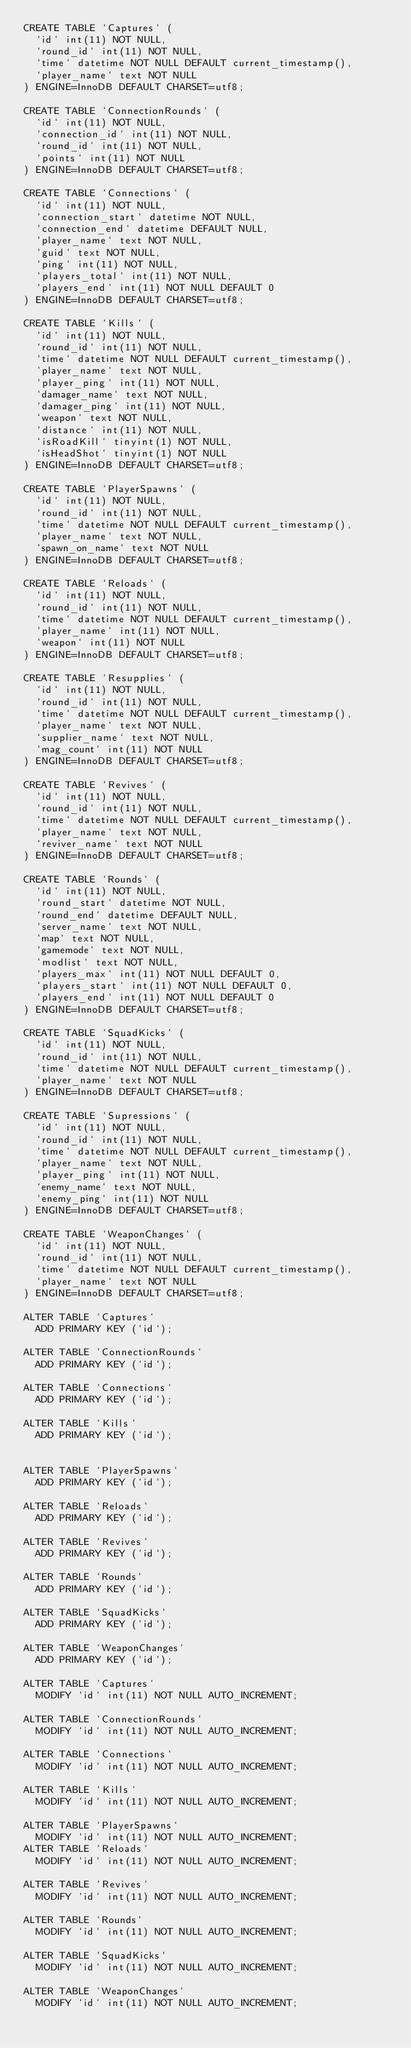Convert code to text. <code><loc_0><loc_0><loc_500><loc_500><_SQL_>CREATE TABLE `Captures` (
  `id` int(11) NOT NULL,
  `round_id` int(11) NOT NULL,
  `time` datetime NOT NULL DEFAULT current_timestamp(),
  `player_name` text NOT NULL
) ENGINE=InnoDB DEFAULT CHARSET=utf8;

CREATE TABLE `ConnectionRounds` (
  `id` int(11) NOT NULL,
  `connection_id` int(11) NOT NULL,
  `round_id` int(11) NOT NULL,
  `points` int(11) NOT NULL
) ENGINE=InnoDB DEFAULT CHARSET=utf8;

CREATE TABLE `Connections` (
  `id` int(11) NOT NULL,
  `connection_start` datetime NOT NULL,
  `connection_end` datetime DEFAULT NULL,
  `player_name` text NOT NULL,
  `guid` text NOT NULL,
  `ping` int(11) NOT NULL,
  `players_total` int(11) NOT NULL,
  `players_end` int(11) NOT NULL DEFAULT 0
) ENGINE=InnoDB DEFAULT CHARSET=utf8;

CREATE TABLE `Kills` (
  `id` int(11) NOT NULL,
  `round_id` int(11) NOT NULL,
  `time` datetime NOT NULL DEFAULT current_timestamp(),
  `player_name` text NOT NULL,
  `player_ping` int(11) NOT NULL,
  `damager_name` text NOT NULL,
  `damager_ping` int(11) NOT NULL,
  `weapon` text NOT NULL,
  `distance` int(11) NOT NULL,
  `isRoadKill` tinyint(1) NOT NULL,
  `isHeadShot` tinyint(1) NOT NULL
) ENGINE=InnoDB DEFAULT CHARSET=utf8;

CREATE TABLE `PlayerSpawns` (
  `id` int(11) NOT NULL,
  `round_id` int(11) NOT NULL,
  `time` datetime NOT NULL DEFAULT current_timestamp(),
  `player_name` text NOT NULL,
  `spawn_on_name` text NOT NULL
) ENGINE=InnoDB DEFAULT CHARSET=utf8;

CREATE TABLE `Reloads` (
  `id` int(11) NOT NULL,
  `round_id` int(11) NOT NULL,
  `time` datetime NOT NULL DEFAULT current_timestamp(),
  `player_name` int(11) NOT NULL,
  `weapon` int(11) NOT NULL
) ENGINE=InnoDB DEFAULT CHARSET=utf8;

CREATE TABLE `Resupplies` (
  `id` int(11) NOT NULL,
  `round_id` int(11) NOT NULL,
  `time` datetime NOT NULL DEFAULT current_timestamp(),
  `player_name` text NOT NULL,
  `supplier_name` text NOT NULL,
  `mag_count` int(11) NOT NULL
) ENGINE=InnoDB DEFAULT CHARSET=utf8;

CREATE TABLE `Revives` (
  `id` int(11) NOT NULL,
  `round_id` int(11) NOT NULL,
  `time` datetime NOT NULL DEFAULT current_timestamp(),
  `player_name` text NOT NULL,
  `reviver_name` text NOT NULL
) ENGINE=InnoDB DEFAULT CHARSET=utf8;

CREATE TABLE `Rounds` (
  `id` int(11) NOT NULL,
  `round_start` datetime NOT NULL,
  `round_end` datetime DEFAULT NULL,
  `server_name` text NOT NULL,
  `map` text NOT NULL,
  `gamemode` text NOT NULL,
  `modlist` text NOT NULL,
  `players_max` int(11) NOT NULL DEFAULT 0,
  `players_start` int(11) NOT NULL DEFAULT 0,
  `players_end` int(11) NOT NULL DEFAULT 0
) ENGINE=InnoDB DEFAULT CHARSET=utf8;

CREATE TABLE `SquadKicks` (
  `id` int(11) NOT NULL,
  `round_id` int(11) NOT NULL,
  `time` datetime NOT NULL DEFAULT current_timestamp(),
  `player_name` text NOT NULL
) ENGINE=InnoDB DEFAULT CHARSET=utf8;

CREATE TABLE `Supressions` (
  `id` int(11) NOT NULL,
  `round_id` int(11) NOT NULL,
  `time` datetime NOT NULL DEFAULT current_timestamp(),
  `player_name` text NOT NULL,
  `player_ping` int(11) NOT NULL,
  `enemy_name` text NOT NULL,
  `enemy_ping` int(11) NOT NULL
) ENGINE=InnoDB DEFAULT CHARSET=utf8;

CREATE TABLE `WeaponChanges` (
  `id` int(11) NOT NULL,
  `round_id` int(11) NOT NULL,
  `time` datetime NOT NULL DEFAULT current_timestamp(),
  `player_name` text NOT NULL
) ENGINE=InnoDB DEFAULT CHARSET=utf8;

ALTER TABLE `Captures`
  ADD PRIMARY KEY (`id`);

ALTER TABLE `ConnectionRounds`
  ADD PRIMARY KEY (`id`);

ALTER TABLE `Connections`
  ADD PRIMARY KEY (`id`);

ALTER TABLE `Kills`
  ADD PRIMARY KEY (`id`);


ALTER TABLE `PlayerSpawns`
  ADD PRIMARY KEY (`id`);

ALTER TABLE `Reloads`
  ADD PRIMARY KEY (`id`);

ALTER TABLE `Revives`
  ADD PRIMARY KEY (`id`);

ALTER TABLE `Rounds`
  ADD PRIMARY KEY (`id`);

ALTER TABLE `SquadKicks`
  ADD PRIMARY KEY (`id`);

ALTER TABLE `WeaponChanges`
  ADD PRIMARY KEY (`id`);

ALTER TABLE `Captures`
  MODIFY `id` int(11) NOT NULL AUTO_INCREMENT;

ALTER TABLE `ConnectionRounds`
  MODIFY `id` int(11) NOT NULL AUTO_INCREMENT;

ALTER TABLE `Connections`
  MODIFY `id` int(11) NOT NULL AUTO_INCREMENT;

ALTER TABLE `Kills`
  MODIFY `id` int(11) NOT NULL AUTO_INCREMENT;

ALTER TABLE `PlayerSpawns`
  MODIFY `id` int(11) NOT NULL AUTO_INCREMENT;
ALTER TABLE `Reloads`
  MODIFY `id` int(11) NOT NULL AUTO_INCREMENT;

ALTER TABLE `Revives`
  MODIFY `id` int(11) NOT NULL AUTO_INCREMENT;

ALTER TABLE `Rounds`
  MODIFY `id` int(11) NOT NULL AUTO_INCREMENT;

ALTER TABLE `SquadKicks`
  MODIFY `id` int(11) NOT NULL AUTO_INCREMENT;

ALTER TABLE `WeaponChanges`
  MODIFY `id` int(11) NOT NULL AUTO_INCREMENT;
</code> 